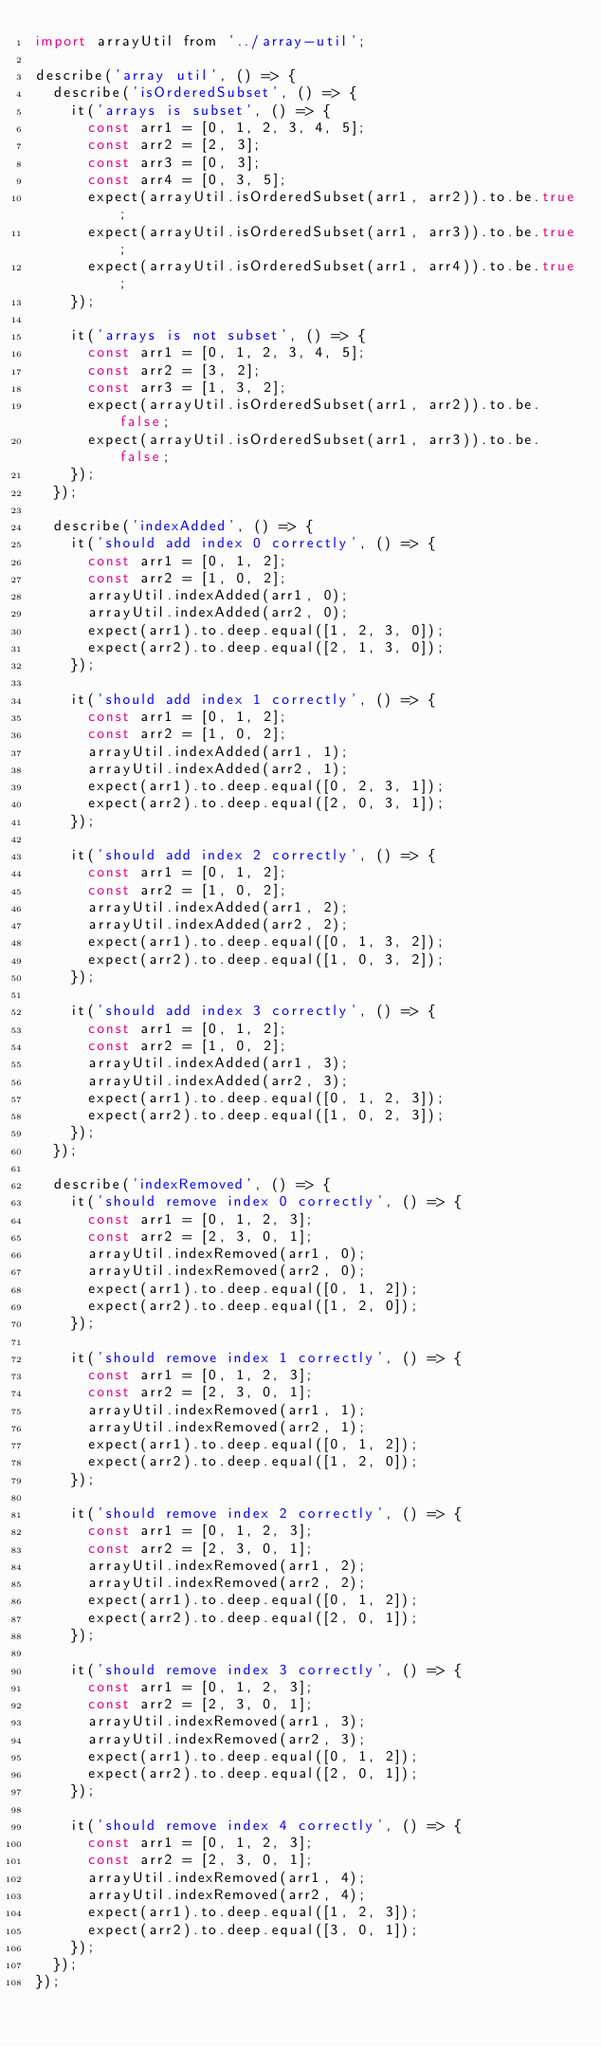Convert code to text. <code><loc_0><loc_0><loc_500><loc_500><_JavaScript_>import arrayUtil from '../array-util';

describe('array util', () => {
  describe('isOrderedSubset', () => {
    it('arrays is subset', () => {
      const arr1 = [0, 1, 2, 3, 4, 5];
      const arr2 = [2, 3];
      const arr3 = [0, 3];
      const arr4 = [0, 3, 5];
      expect(arrayUtil.isOrderedSubset(arr1, arr2)).to.be.true;
      expect(arrayUtil.isOrderedSubset(arr1, arr3)).to.be.true;
      expect(arrayUtil.isOrderedSubset(arr1, arr4)).to.be.true;
    });

    it('arrays is not subset', () => {
      const arr1 = [0, 1, 2, 3, 4, 5];
      const arr2 = [3, 2];
      const arr3 = [1, 3, 2];
      expect(arrayUtil.isOrderedSubset(arr1, arr2)).to.be.false;
      expect(arrayUtil.isOrderedSubset(arr1, arr3)).to.be.false;
    });
  });

  describe('indexAdded', () => {
    it('should add index 0 correctly', () => {
      const arr1 = [0, 1, 2];
      const arr2 = [1, 0, 2];
      arrayUtil.indexAdded(arr1, 0);
      arrayUtil.indexAdded(arr2, 0);
      expect(arr1).to.deep.equal([1, 2, 3, 0]);
      expect(arr2).to.deep.equal([2, 1, 3, 0]);
    });

    it('should add index 1 correctly', () => {
      const arr1 = [0, 1, 2];
      const arr2 = [1, 0, 2];
      arrayUtil.indexAdded(arr1, 1);
      arrayUtil.indexAdded(arr2, 1);
      expect(arr1).to.deep.equal([0, 2, 3, 1]);
      expect(arr2).to.deep.equal([2, 0, 3, 1]);
    });

    it('should add index 2 correctly', () => {
      const arr1 = [0, 1, 2];
      const arr2 = [1, 0, 2];
      arrayUtil.indexAdded(arr1, 2);
      arrayUtil.indexAdded(arr2, 2);
      expect(arr1).to.deep.equal([0, 1, 3, 2]);
      expect(arr2).to.deep.equal([1, 0, 3, 2]);
    });

    it('should add index 3 correctly', () => {
      const arr1 = [0, 1, 2];
      const arr2 = [1, 0, 2];
      arrayUtil.indexAdded(arr1, 3);
      arrayUtil.indexAdded(arr2, 3);
      expect(arr1).to.deep.equal([0, 1, 2, 3]);
      expect(arr2).to.deep.equal([1, 0, 2, 3]);
    });
  });

  describe('indexRemoved', () => {
    it('should remove index 0 correctly', () => {
      const arr1 = [0, 1, 2, 3];
      const arr2 = [2, 3, 0, 1];
      arrayUtil.indexRemoved(arr1, 0);
      arrayUtil.indexRemoved(arr2, 0);
      expect(arr1).to.deep.equal([0, 1, 2]);
      expect(arr2).to.deep.equal([1, 2, 0]);
    });

    it('should remove index 1 correctly', () => {
      const arr1 = [0, 1, 2, 3];
      const arr2 = [2, 3, 0, 1];
      arrayUtil.indexRemoved(arr1, 1);
      arrayUtil.indexRemoved(arr2, 1);
      expect(arr1).to.deep.equal([0, 1, 2]);
      expect(arr2).to.deep.equal([1, 2, 0]);
    });

    it('should remove index 2 correctly', () => {
      const arr1 = [0, 1, 2, 3];
      const arr2 = [2, 3, 0, 1];
      arrayUtil.indexRemoved(arr1, 2);
      arrayUtil.indexRemoved(arr2, 2);
      expect(arr1).to.deep.equal([0, 1, 2]);
      expect(arr2).to.deep.equal([2, 0, 1]);
    });

    it('should remove index 3 correctly', () => {
      const arr1 = [0, 1, 2, 3];
      const arr2 = [2, 3, 0, 1];
      arrayUtil.indexRemoved(arr1, 3);
      arrayUtil.indexRemoved(arr2, 3);
      expect(arr1).to.deep.equal([0, 1, 2]);
      expect(arr2).to.deep.equal([2, 0, 1]);
    });

    it('should remove index 4 correctly', () => {
      const arr1 = [0, 1, 2, 3];
      const arr2 = [2, 3, 0, 1];
      arrayUtil.indexRemoved(arr1, 4);
      arrayUtil.indexRemoved(arr2, 4);
      expect(arr1).to.deep.equal([1, 2, 3]);
      expect(arr2).to.deep.equal([3, 0, 1]);
    });
  });
});
</code> 